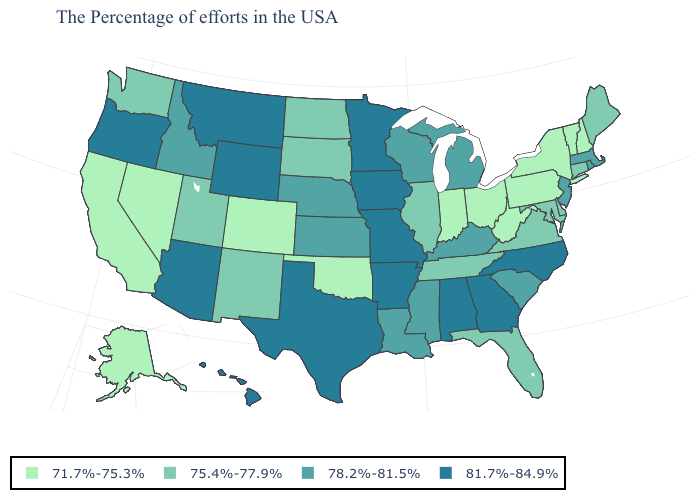Is the legend a continuous bar?
Concise answer only. No. Does Utah have a lower value than New Jersey?
Concise answer only. Yes. Name the states that have a value in the range 75.4%-77.9%?
Concise answer only. Maine, Connecticut, Delaware, Maryland, Virginia, Florida, Tennessee, Illinois, South Dakota, North Dakota, New Mexico, Utah, Washington. How many symbols are there in the legend?
Keep it brief. 4. What is the value of Delaware?
Answer briefly. 75.4%-77.9%. Name the states that have a value in the range 81.7%-84.9%?
Write a very short answer. North Carolina, Georgia, Alabama, Missouri, Arkansas, Minnesota, Iowa, Texas, Wyoming, Montana, Arizona, Oregon, Hawaii. Name the states that have a value in the range 75.4%-77.9%?
Be succinct. Maine, Connecticut, Delaware, Maryland, Virginia, Florida, Tennessee, Illinois, South Dakota, North Dakota, New Mexico, Utah, Washington. Does Ohio have the lowest value in the USA?
Short answer required. Yes. Does Louisiana have the highest value in the USA?
Keep it brief. No. What is the lowest value in the West?
Answer briefly. 71.7%-75.3%. Does Idaho have the lowest value in the USA?
Answer briefly. No. What is the value of Nevada?
Answer briefly. 71.7%-75.3%. What is the highest value in the USA?
Write a very short answer. 81.7%-84.9%. What is the lowest value in the USA?
Short answer required. 71.7%-75.3%. What is the lowest value in the USA?
Give a very brief answer. 71.7%-75.3%. 